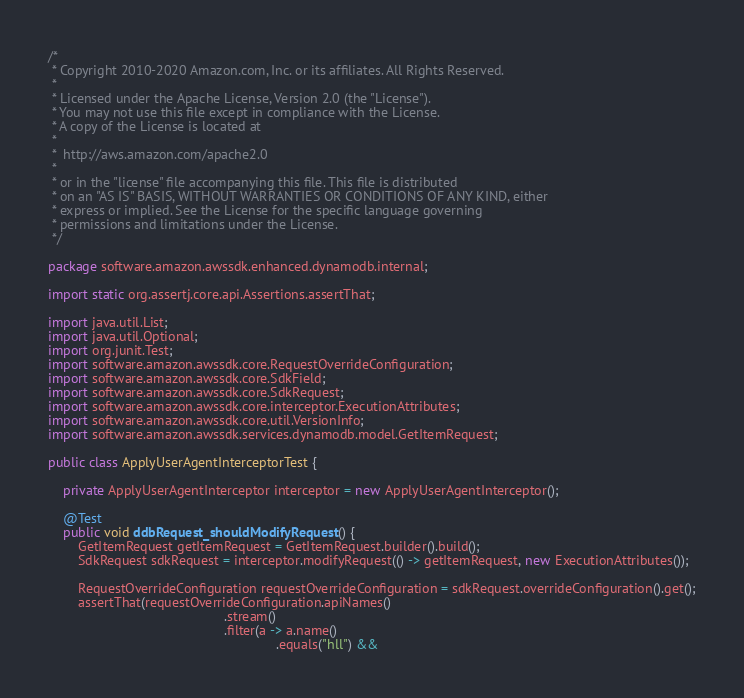Convert code to text. <code><loc_0><loc_0><loc_500><loc_500><_Java_>/*
 * Copyright 2010-2020 Amazon.com, Inc. or its affiliates. All Rights Reserved.
 *
 * Licensed under the Apache License, Version 2.0 (the "License").
 * You may not use this file except in compliance with the License.
 * A copy of the License is located at
 *
 *  http://aws.amazon.com/apache2.0
 *
 * or in the "license" file accompanying this file. This file is distributed
 * on an "AS IS" BASIS, WITHOUT WARRANTIES OR CONDITIONS OF ANY KIND, either
 * express or implied. See the License for the specific language governing
 * permissions and limitations under the License.
 */

package software.amazon.awssdk.enhanced.dynamodb.internal;

import static org.assertj.core.api.Assertions.assertThat;

import java.util.List;
import java.util.Optional;
import org.junit.Test;
import software.amazon.awssdk.core.RequestOverrideConfiguration;
import software.amazon.awssdk.core.SdkField;
import software.amazon.awssdk.core.SdkRequest;
import software.amazon.awssdk.core.interceptor.ExecutionAttributes;
import software.amazon.awssdk.core.util.VersionInfo;
import software.amazon.awssdk.services.dynamodb.model.GetItemRequest;

public class ApplyUserAgentInterceptorTest {

    private ApplyUserAgentInterceptor interceptor = new ApplyUserAgentInterceptor();

    @Test
    public void ddbRequest_shouldModifyRequest() {
        GetItemRequest getItemRequest = GetItemRequest.builder().build();
        SdkRequest sdkRequest = interceptor.modifyRequest(() -> getItemRequest, new ExecutionAttributes());

        RequestOverrideConfiguration requestOverrideConfiguration = sdkRequest.overrideConfiguration().get();
        assertThat(requestOverrideConfiguration.apiNames()
                                               .stream()
                                               .filter(a -> a.name()
                                                             .equals("hll") &&</code> 